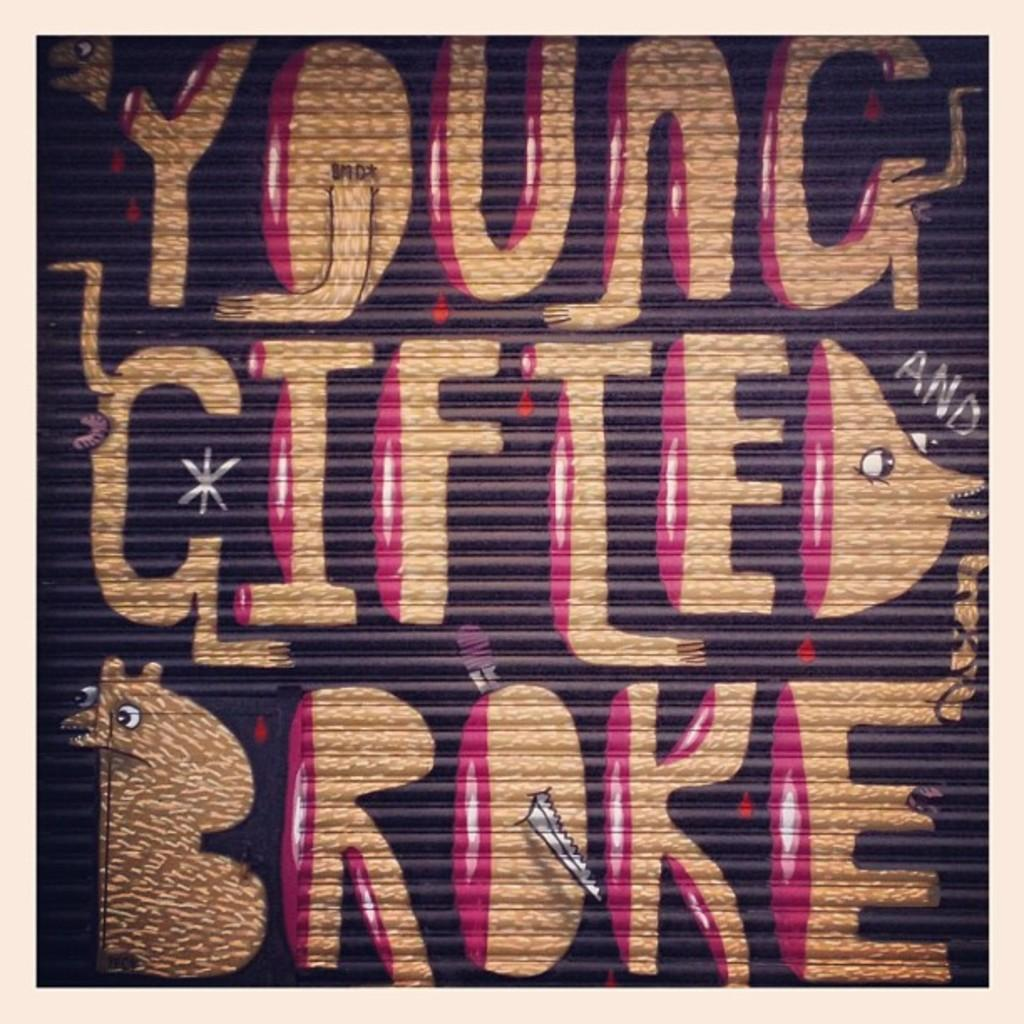<image>
Create a compact narrative representing the image presented. a garage door with young gifted broke on it 